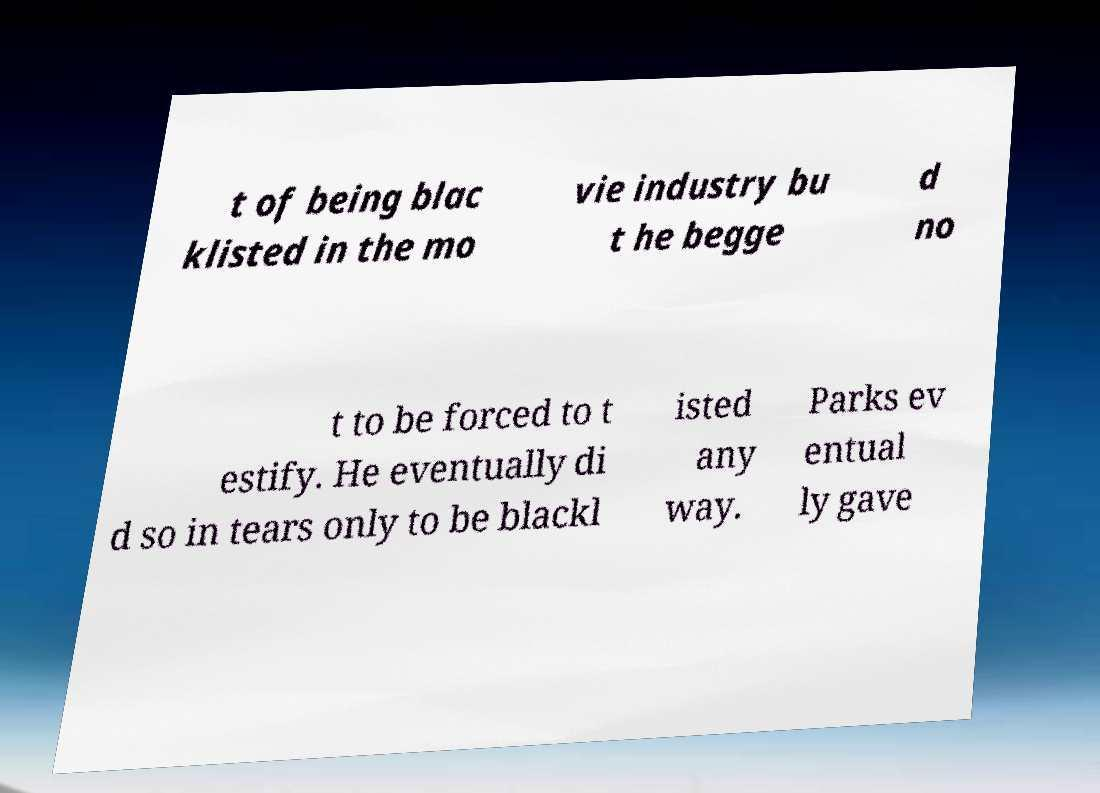I need the written content from this picture converted into text. Can you do that? t of being blac klisted in the mo vie industry bu t he begge d no t to be forced to t estify. He eventually di d so in tears only to be blackl isted any way. Parks ev entual ly gave 